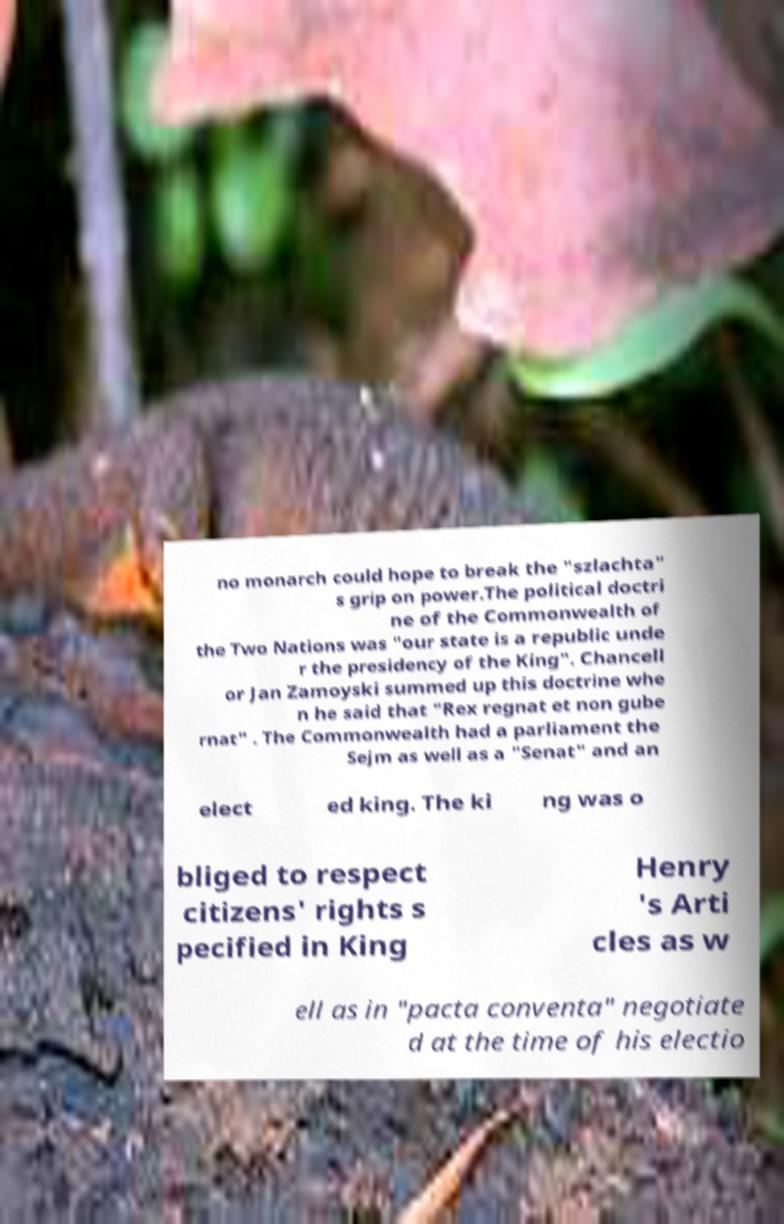For documentation purposes, I need the text within this image transcribed. Could you provide that? no monarch could hope to break the "szlachta" s grip on power.The political doctri ne of the Commonwealth of the Two Nations was "our state is a republic unde r the presidency of the King". Chancell or Jan Zamoyski summed up this doctrine whe n he said that "Rex regnat et non gube rnat" . The Commonwealth had a parliament the Sejm as well as a "Senat" and an elect ed king. The ki ng was o bliged to respect citizens' rights s pecified in King Henry 's Arti cles as w ell as in "pacta conventa" negotiate d at the time of his electio 